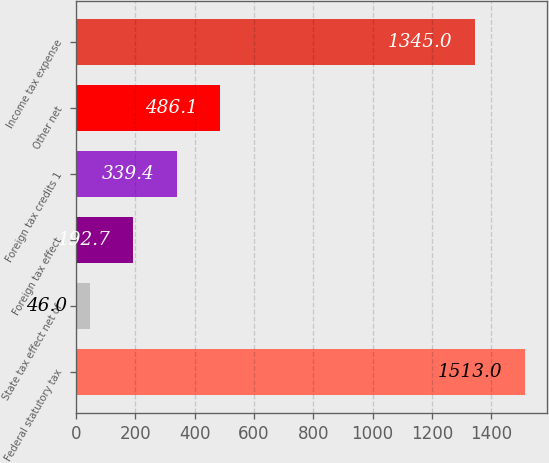Convert chart to OTSL. <chart><loc_0><loc_0><loc_500><loc_500><bar_chart><fcel>Federal statutory tax<fcel>State tax effect net of<fcel>Foreign tax effect<fcel>Foreign tax credits 1<fcel>Other net<fcel>Income tax expense<nl><fcel>1513<fcel>46<fcel>192.7<fcel>339.4<fcel>486.1<fcel>1345<nl></chart> 